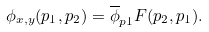Convert formula to latex. <formula><loc_0><loc_0><loc_500><loc_500>\phi _ { x , y } ( p _ { 1 } , p _ { 2 } ) = \overline { \phi } _ { p 1 } F ( p _ { 2 } , p _ { 1 } ) .</formula> 